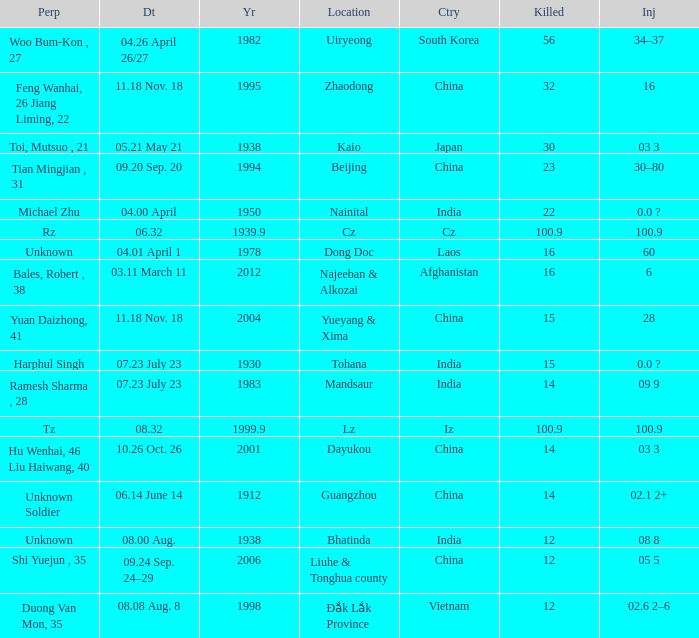What suffers injuries when the location is afghanistan? 6.0. 